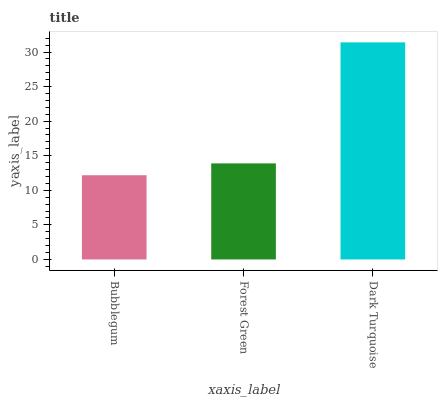Is Dark Turquoise the maximum?
Answer yes or no. Yes. Is Forest Green the minimum?
Answer yes or no. No. Is Forest Green the maximum?
Answer yes or no. No. Is Forest Green greater than Bubblegum?
Answer yes or no. Yes. Is Bubblegum less than Forest Green?
Answer yes or no. Yes. Is Bubblegum greater than Forest Green?
Answer yes or no. No. Is Forest Green less than Bubblegum?
Answer yes or no. No. Is Forest Green the high median?
Answer yes or no. Yes. Is Forest Green the low median?
Answer yes or no. Yes. Is Bubblegum the high median?
Answer yes or no. No. Is Bubblegum the low median?
Answer yes or no. No. 